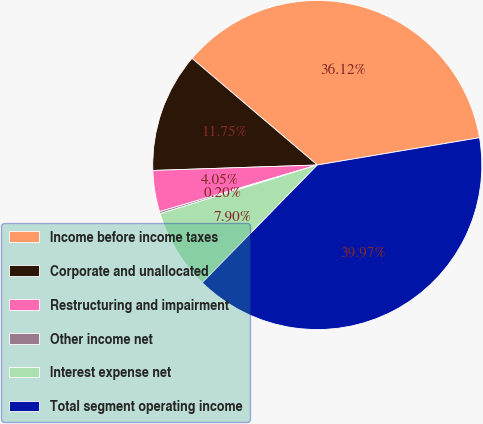Convert chart. <chart><loc_0><loc_0><loc_500><loc_500><pie_chart><fcel>Income before income taxes<fcel>Corporate and unallocated<fcel>Restructuring and impairment<fcel>Other income net<fcel>Interest expense net<fcel>Total segment operating income<nl><fcel>36.12%<fcel>11.75%<fcel>4.05%<fcel>0.2%<fcel>7.9%<fcel>39.97%<nl></chart> 